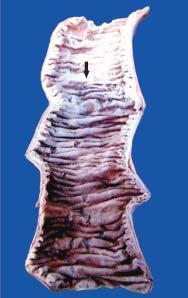s the interface between viable and non-viable area soft, swollen and dark?
Answer the question using a single word or phrase. No 